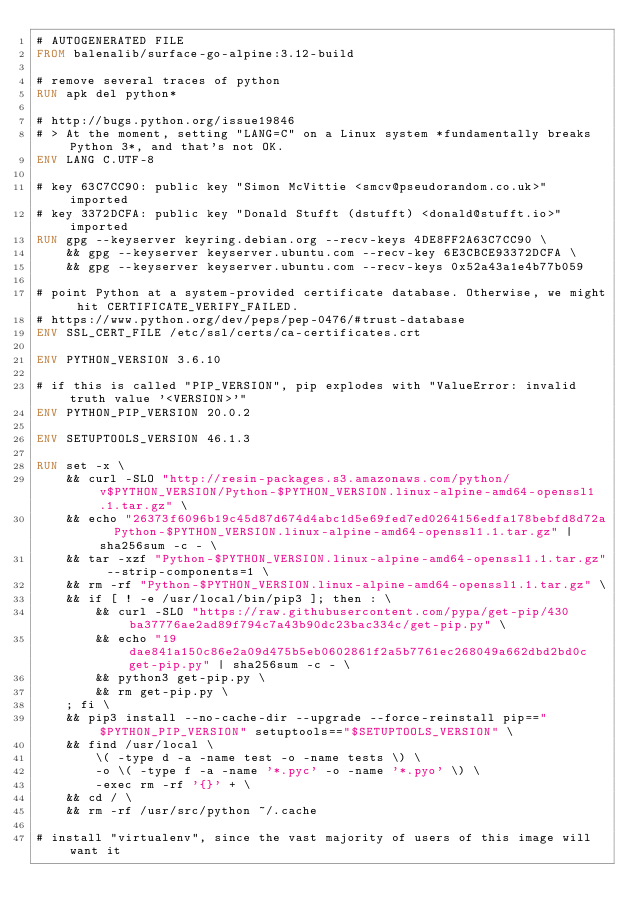Convert code to text. <code><loc_0><loc_0><loc_500><loc_500><_Dockerfile_># AUTOGENERATED FILE
FROM balenalib/surface-go-alpine:3.12-build

# remove several traces of python
RUN apk del python*

# http://bugs.python.org/issue19846
# > At the moment, setting "LANG=C" on a Linux system *fundamentally breaks Python 3*, and that's not OK.
ENV LANG C.UTF-8

# key 63C7CC90: public key "Simon McVittie <smcv@pseudorandom.co.uk>" imported
# key 3372DCFA: public key "Donald Stufft (dstufft) <donald@stufft.io>" imported
RUN gpg --keyserver keyring.debian.org --recv-keys 4DE8FF2A63C7CC90 \
	&& gpg --keyserver keyserver.ubuntu.com --recv-key 6E3CBCE93372DCFA \
	&& gpg --keyserver keyserver.ubuntu.com --recv-keys 0x52a43a1e4b77b059

# point Python at a system-provided certificate database. Otherwise, we might hit CERTIFICATE_VERIFY_FAILED.
# https://www.python.org/dev/peps/pep-0476/#trust-database
ENV SSL_CERT_FILE /etc/ssl/certs/ca-certificates.crt

ENV PYTHON_VERSION 3.6.10

# if this is called "PIP_VERSION", pip explodes with "ValueError: invalid truth value '<VERSION>'"
ENV PYTHON_PIP_VERSION 20.0.2

ENV SETUPTOOLS_VERSION 46.1.3

RUN set -x \
	&& curl -SLO "http://resin-packages.s3.amazonaws.com/python/v$PYTHON_VERSION/Python-$PYTHON_VERSION.linux-alpine-amd64-openssl1.1.tar.gz" \
	&& echo "26373f6096b19c45d87d674d4abc1d5e69fed7ed0264156edfa178bebfd8d72a  Python-$PYTHON_VERSION.linux-alpine-amd64-openssl1.1.tar.gz" | sha256sum -c - \
	&& tar -xzf "Python-$PYTHON_VERSION.linux-alpine-amd64-openssl1.1.tar.gz" --strip-components=1 \
	&& rm -rf "Python-$PYTHON_VERSION.linux-alpine-amd64-openssl1.1.tar.gz" \
	&& if [ ! -e /usr/local/bin/pip3 ]; then : \
		&& curl -SLO "https://raw.githubusercontent.com/pypa/get-pip/430ba37776ae2ad89f794c7a43b90dc23bac334c/get-pip.py" \
		&& echo "19dae841a150c86e2a09d475b5eb0602861f2a5b7761ec268049a662dbd2bd0c  get-pip.py" | sha256sum -c - \
		&& python3 get-pip.py \
		&& rm get-pip.py \
	; fi \
	&& pip3 install --no-cache-dir --upgrade --force-reinstall pip=="$PYTHON_PIP_VERSION" setuptools=="$SETUPTOOLS_VERSION" \
	&& find /usr/local \
		\( -type d -a -name test -o -name tests \) \
		-o \( -type f -a -name '*.pyc' -o -name '*.pyo' \) \
		-exec rm -rf '{}' + \
	&& cd / \
	&& rm -rf /usr/src/python ~/.cache

# install "virtualenv", since the vast majority of users of this image will want it</code> 